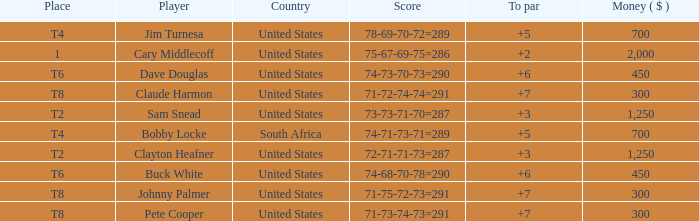What is the Johnny Palmer with a To larger than 6 Money sum? 300.0. 